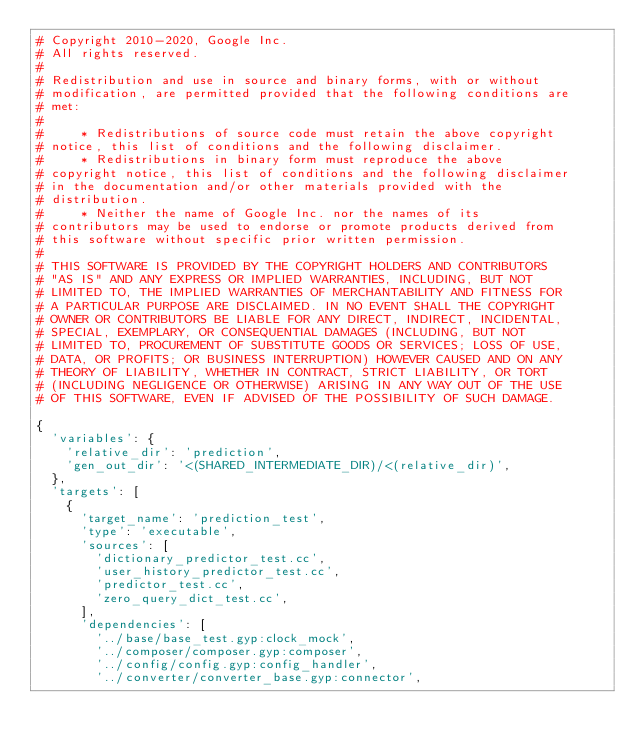<code> <loc_0><loc_0><loc_500><loc_500><_Python_># Copyright 2010-2020, Google Inc.
# All rights reserved.
#
# Redistribution and use in source and binary forms, with or without
# modification, are permitted provided that the following conditions are
# met:
#
#     * Redistributions of source code must retain the above copyright
# notice, this list of conditions and the following disclaimer.
#     * Redistributions in binary form must reproduce the above
# copyright notice, this list of conditions and the following disclaimer
# in the documentation and/or other materials provided with the
# distribution.
#     * Neither the name of Google Inc. nor the names of its
# contributors may be used to endorse or promote products derived from
# this software without specific prior written permission.
#
# THIS SOFTWARE IS PROVIDED BY THE COPYRIGHT HOLDERS AND CONTRIBUTORS
# "AS IS" AND ANY EXPRESS OR IMPLIED WARRANTIES, INCLUDING, BUT NOT
# LIMITED TO, THE IMPLIED WARRANTIES OF MERCHANTABILITY AND FITNESS FOR
# A PARTICULAR PURPOSE ARE DISCLAIMED. IN NO EVENT SHALL THE COPYRIGHT
# OWNER OR CONTRIBUTORS BE LIABLE FOR ANY DIRECT, INDIRECT, INCIDENTAL,
# SPECIAL, EXEMPLARY, OR CONSEQUENTIAL DAMAGES (INCLUDING, BUT NOT
# LIMITED TO, PROCUREMENT OF SUBSTITUTE GOODS OR SERVICES; LOSS OF USE,
# DATA, OR PROFITS; OR BUSINESS INTERRUPTION) HOWEVER CAUSED AND ON ANY
# THEORY OF LIABILITY, WHETHER IN CONTRACT, STRICT LIABILITY, OR TORT
# (INCLUDING NEGLIGENCE OR OTHERWISE) ARISING IN ANY WAY OUT OF THE USE
# OF THIS SOFTWARE, EVEN IF ADVISED OF THE POSSIBILITY OF SUCH DAMAGE.

{
  'variables': {
    'relative_dir': 'prediction',
    'gen_out_dir': '<(SHARED_INTERMEDIATE_DIR)/<(relative_dir)',
  },
  'targets': [
    {
      'target_name': 'prediction_test',
      'type': 'executable',
      'sources': [
        'dictionary_predictor_test.cc',
        'user_history_predictor_test.cc',
        'predictor_test.cc',
        'zero_query_dict_test.cc',
      ],
      'dependencies': [
        '../base/base_test.gyp:clock_mock',
        '../composer/composer.gyp:composer',
        '../config/config.gyp:config_handler',
        '../converter/converter_base.gyp:connector',</code> 